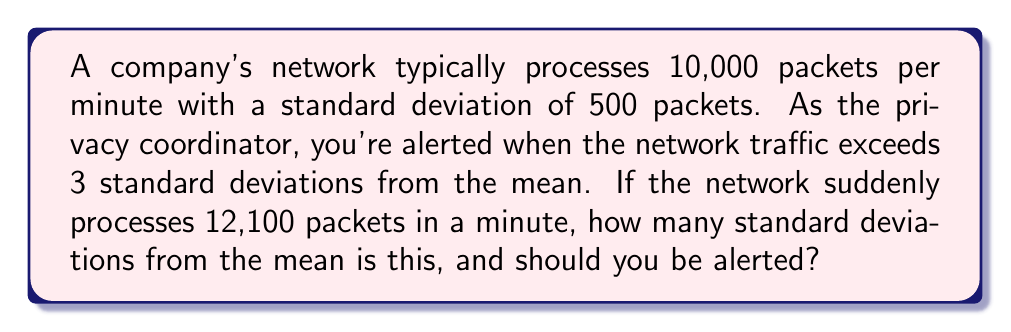Teach me how to tackle this problem. Let's approach this step-by-step:

1) We're given:
   - Mean (μ) = 10,000 packets per minute
   - Standard deviation (σ) = 500 packets
   - Current traffic = 12,100 packets

2) To find how many standard deviations the current traffic is from the mean, we use the z-score formula:

   $$ z = \frac{x - \mu}{\sigma} $$

   Where:
   $x$ = observed value
   $\mu$ = mean
   $\sigma$ = standard deviation

3) Let's plug in our values:

   $$ z = \frac{12,100 - 10,000}{500} $$

4) Simplify:

   $$ z = \frac{2,100}{500} = 4.2 $$

5) The result, 4.2, means the current traffic is 4.2 standard deviations above the mean.

6) We're told to be alerted when traffic exceeds 3 standard deviations from the mean.

7) Since 4.2 > 3, this traffic pattern should trigger an alert.
Answer: 4.2 standard deviations; Yes, alert 